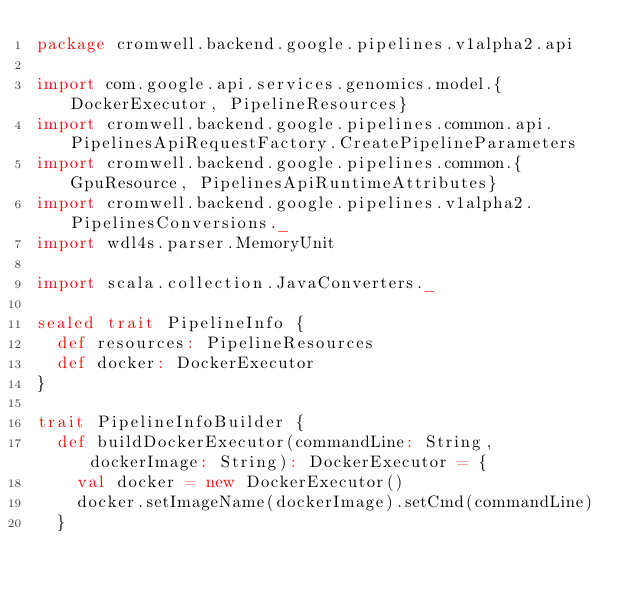Convert code to text. <code><loc_0><loc_0><loc_500><loc_500><_Scala_>package cromwell.backend.google.pipelines.v1alpha2.api

import com.google.api.services.genomics.model.{DockerExecutor, PipelineResources}
import cromwell.backend.google.pipelines.common.api.PipelinesApiRequestFactory.CreatePipelineParameters
import cromwell.backend.google.pipelines.common.{GpuResource, PipelinesApiRuntimeAttributes}
import cromwell.backend.google.pipelines.v1alpha2.PipelinesConversions._
import wdl4s.parser.MemoryUnit

import scala.collection.JavaConverters._

sealed trait PipelineInfo {
  def resources: PipelineResources
  def docker: DockerExecutor
}

trait PipelineInfoBuilder {
  def buildDockerExecutor(commandLine: String, dockerImage: String): DockerExecutor = {
    val docker = new DockerExecutor()
    docker.setImageName(dockerImage).setCmd(commandLine)
  }
  </code> 